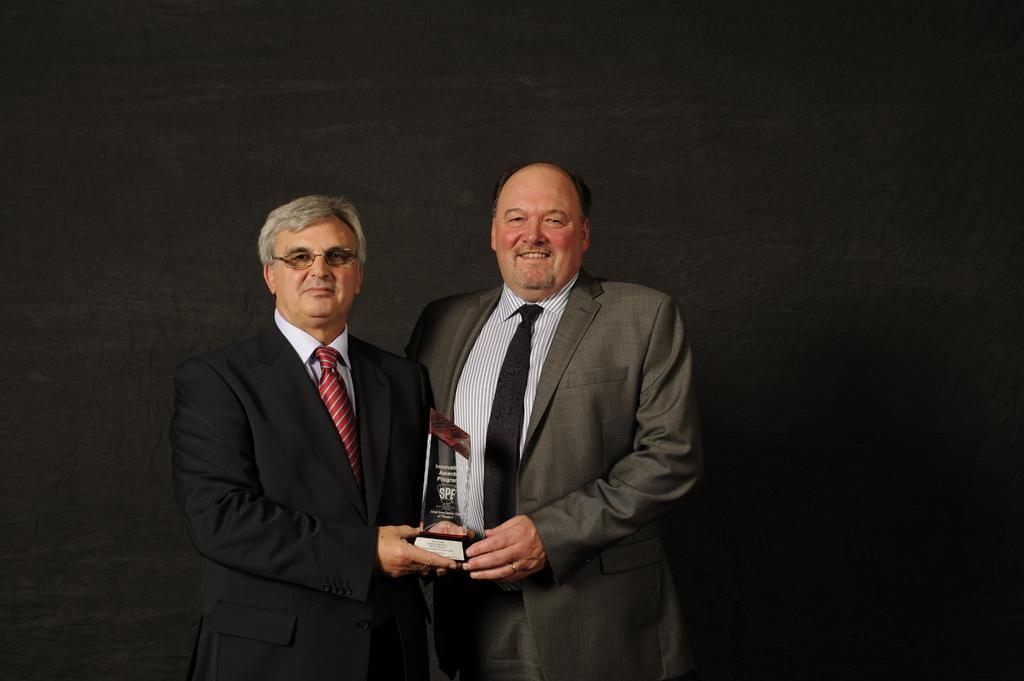How many people are in the image? There are two persons in the image. What are the persons wearing? Both persons are wearing a suit and tie. What are the persons doing in the image? The persons are standing and holding an award in their hands. What can be seen in the background of the image? There is a wall in the background of the image. What type of brass instrument is being played by the persons in the image? There is no brass instrument present in the image; the persons are holding an award. What invention is being celebrated in the image? The image does not provide information about any specific invention being celebrated. 